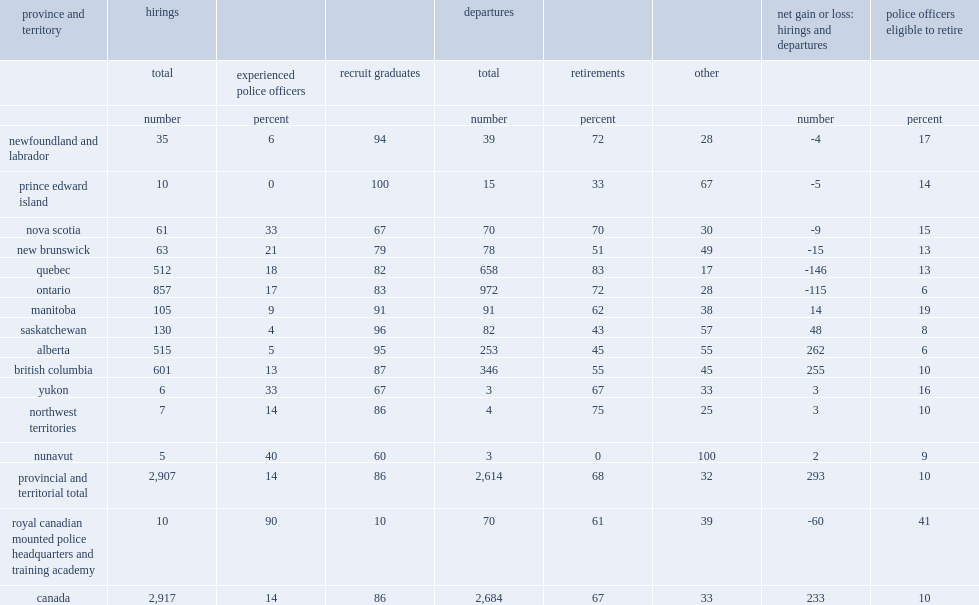In 2016/2017, how many police officers were hired by police services in canada? 2917.0. In 2016/2017, which group was the majority of police officers hired by police services in canada, experienced police officers or recruit graduates? Recruit graduates. In 2016/2017, what was the percentage of recruit graduates in the police officers hired by police services in canada? 86.0. In 2016/2017, what was the percentage of experienced officers in the police officers hired by police services in canada? 14.0. 